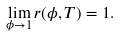<formula> <loc_0><loc_0><loc_500><loc_500>\lim _ { \phi \rightarrow 1 } r ( \phi , T ) = 1 .</formula> 